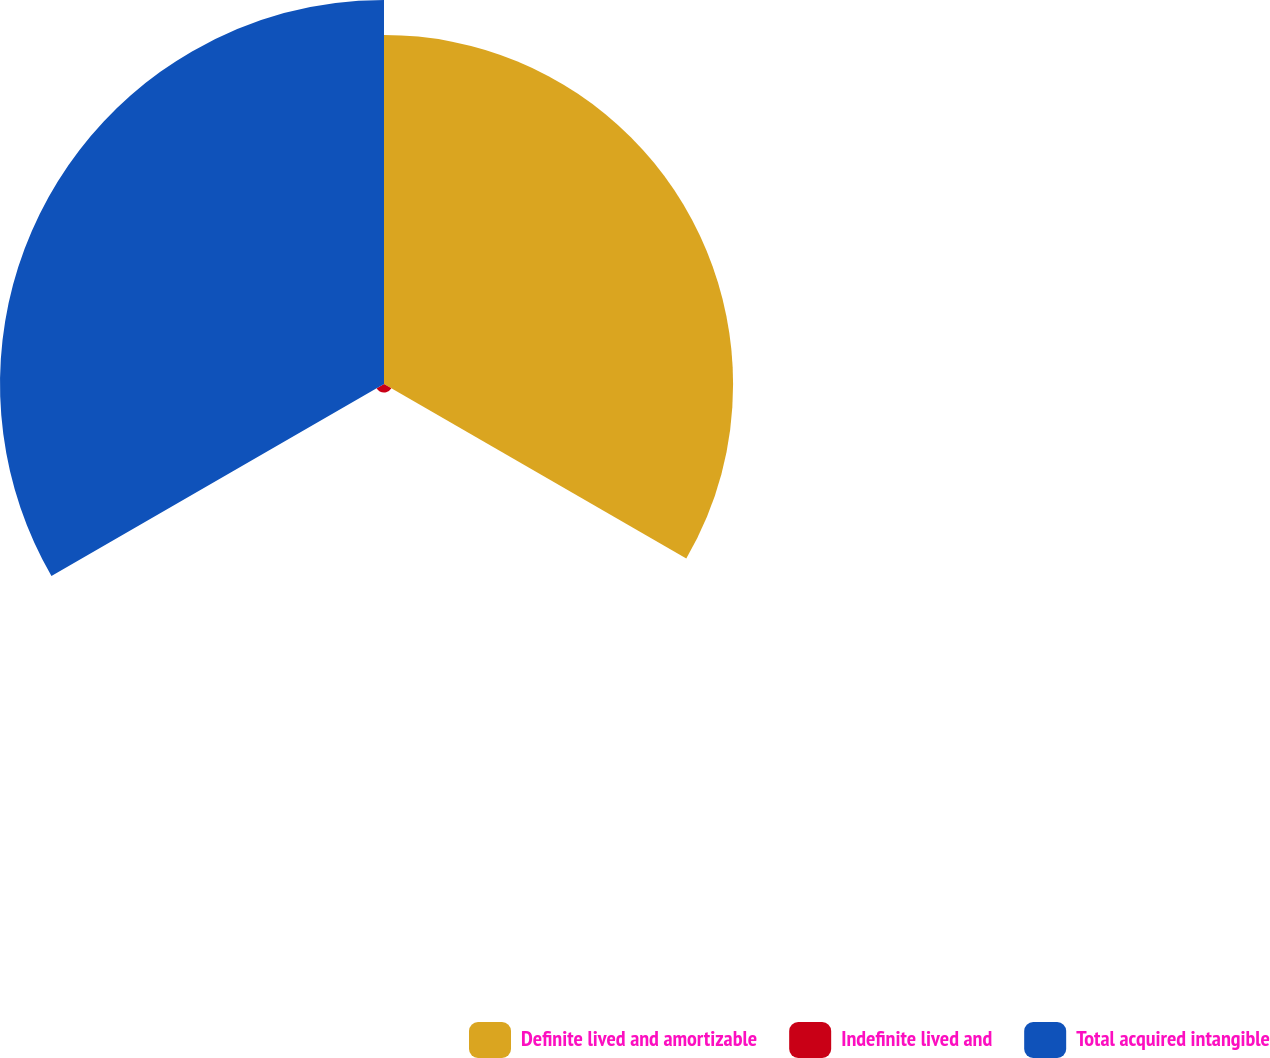<chart> <loc_0><loc_0><loc_500><loc_500><pie_chart><fcel>Definite lived and amortizable<fcel>Indefinite lived and<fcel>Total acquired intangible<nl><fcel>47.07%<fcel>1.15%<fcel>51.78%<nl></chart> 